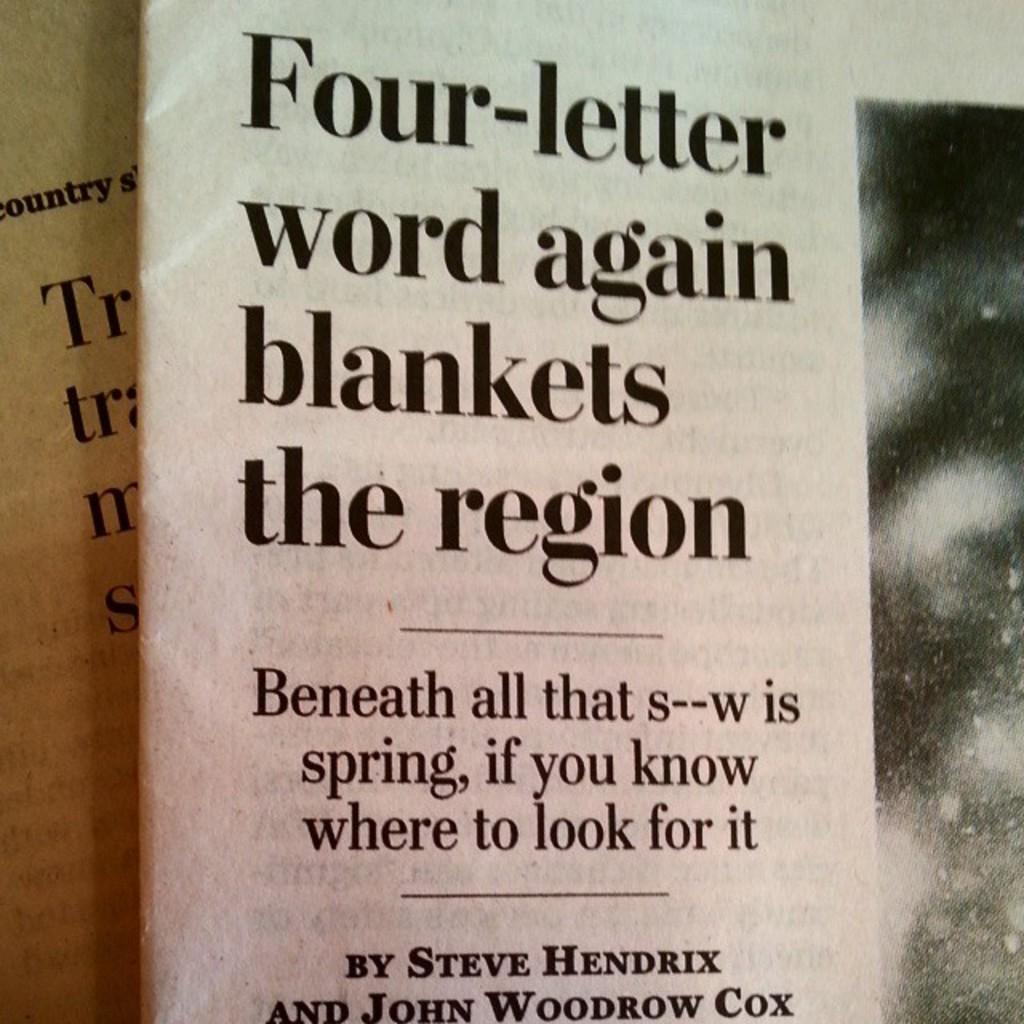<image>
Relay a brief, clear account of the picture shown. A newspaper article written by Steve Hendrix and John Woodrow Cox references the weather. 